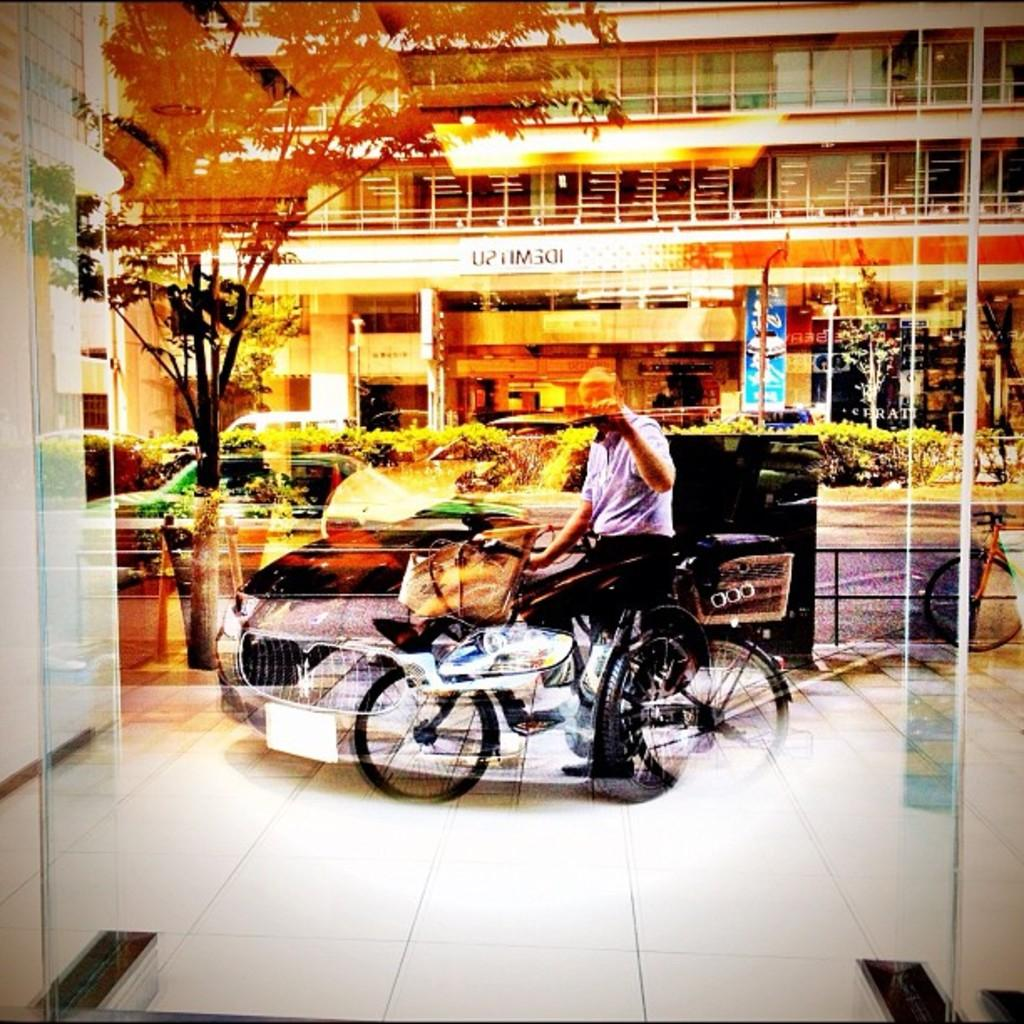What type of natural elements can be seen in the image? There are trees in the image. What type of man-made objects can be seen in the image? There are cars in the image. Can you describe the human presence in the image? There is a man in the image. What type of ink is the man using to write on the trees in the image? There is no indication in the image that the man is writing on the trees or using ink. 